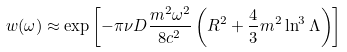Convert formula to latex. <formula><loc_0><loc_0><loc_500><loc_500>w ( \omega ) \approx \exp \left [ - \pi \nu D \frac { m ^ { 2 } \omega ^ { 2 } } { 8 c ^ { 2 } } \left ( R ^ { 2 } + \frac { 4 } { 3 } m ^ { 2 } \ln ^ { 3 } \Lambda \right ) \right ]</formula> 